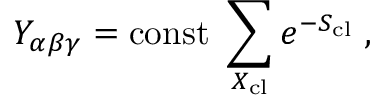<formula> <loc_0><loc_0><loc_500><loc_500>Y _ { \alpha \beta \gamma } = c o n s t \sum _ { X _ { c l } } e ^ { - S _ { c l } } \, ,</formula> 